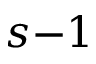<formula> <loc_0><loc_0><loc_500><loc_500>s { - 1 }</formula> 